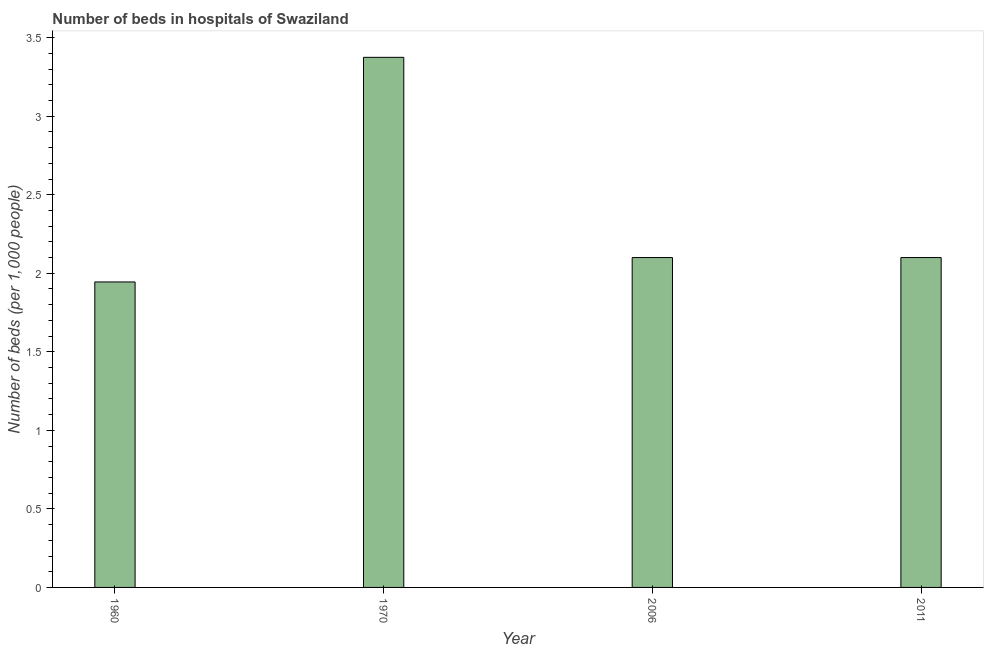Does the graph contain any zero values?
Give a very brief answer. No. Does the graph contain grids?
Offer a terse response. No. What is the title of the graph?
Offer a terse response. Number of beds in hospitals of Swaziland. What is the label or title of the X-axis?
Your answer should be very brief. Year. What is the label or title of the Y-axis?
Keep it short and to the point. Number of beds (per 1,0 people). What is the number of hospital beds in 1960?
Provide a succinct answer. 1.94. Across all years, what is the maximum number of hospital beds?
Your answer should be very brief. 3.37. Across all years, what is the minimum number of hospital beds?
Your response must be concise. 1.94. What is the sum of the number of hospital beds?
Offer a terse response. 9.52. What is the average number of hospital beds per year?
Offer a terse response. 2.38. Do a majority of the years between 2006 and 1970 (inclusive) have number of hospital beds greater than 1.2 %?
Keep it short and to the point. No. What is the ratio of the number of hospital beds in 1960 to that in 2011?
Provide a succinct answer. 0.93. What is the difference between the highest and the second highest number of hospital beds?
Give a very brief answer. 1.27. What is the difference between the highest and the lowest number of hospital beds?
Your answer should be compact. 1.43. In how many years, is the number of hospital beds greater than the average number of hospital beds taken over all years?
Provide a succinct answer. 1. Are all the bars in the graph horizontal?
Offer a very short reply. No. How many years are there in the graph?
Your answer should be very brief. 4. What is the Number of beds (per 1,000 people) of 1960?
Provide a succinct answer. 1.94. What is the Number of beds (per 1,000 people) in 1970?
Ensure brevity in your answer.  3.37. What is the Number of beds (per 1,000 people) of 2011?
Your response must be concise. 2.1. What is the difference between the Number of beds (per 1,000 people) in 1960 and 1970?
Provide a short and direct response. -1.43. What is the difference between the Number of beds (per 1,000 people) in 1960 and 2006?
Provide a short and direct response. -0.16. What is the difference between the Number of beds (per 1,000 people) in 1960 and 2011?
Offer a terse response. -0.16. What is the difference between the Number of beds (per 1,000 people) in 1970 and 2006?
Give a very brief answer. 1.27. What is the difference between the Number of beds (per 1,000 people) in 1970 and 2011?
Provide a succinct answer. 1.27. What is the ratio of the Number of beds (per 1,000 people) in 1960 to that in 1970?
Provide a succinct answer. 0.58. What is the ratio of the Number of beds (per 1,000 people) in 1960 to that in 2006?
Provide a short and direct response. 0.93. What is the ratio of the Number of beds (per 1,000 people) in 1960 to that in 2011?
Offer a terse response. 0.93. What is the ratio of the Number of beds (per 1,000 people) in 1970 to that in 2006?
Provide a short and direct response. 1.61. What is the ratio of the Number of beds (per 1,000 people) in 1970 to that in 2011?
Your answer should be very brief. 1.61. 